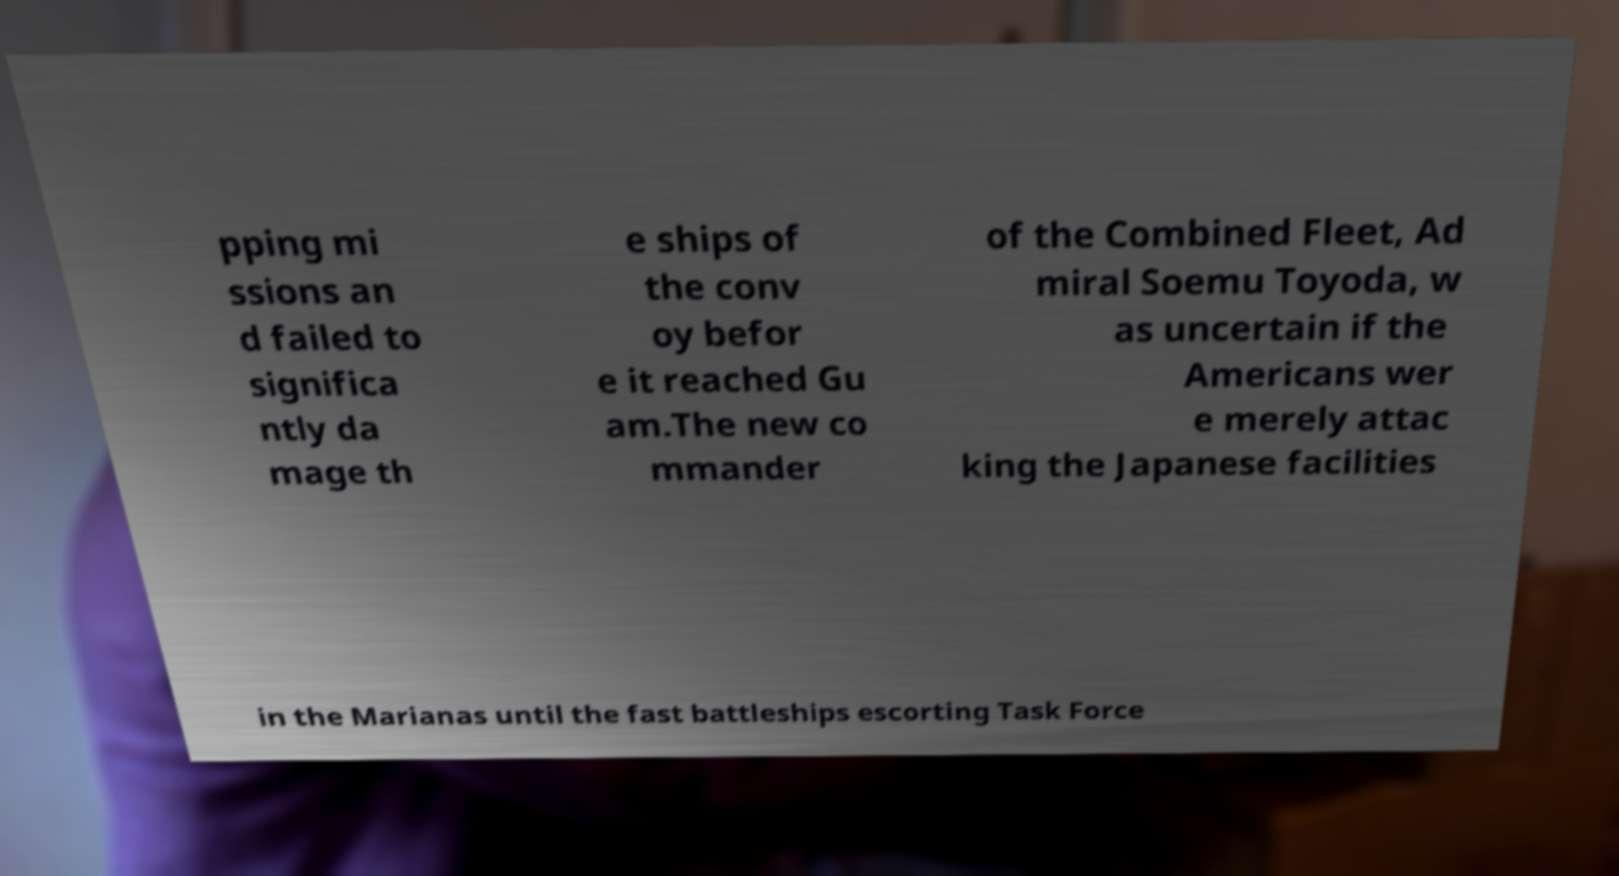Please identify and transcribe the text found in this image. pping mi ssions an d failed to significa ntly da mage th e ships of the conv oy befor e it reached Gu am.The new co mmander of the Combined Fleet, Ad miral Soemu Toyoda, w as uncertain if the Americans wer e merely attac king the Japanese facilities in the Marianas until the fast battleships escorting Task Force 